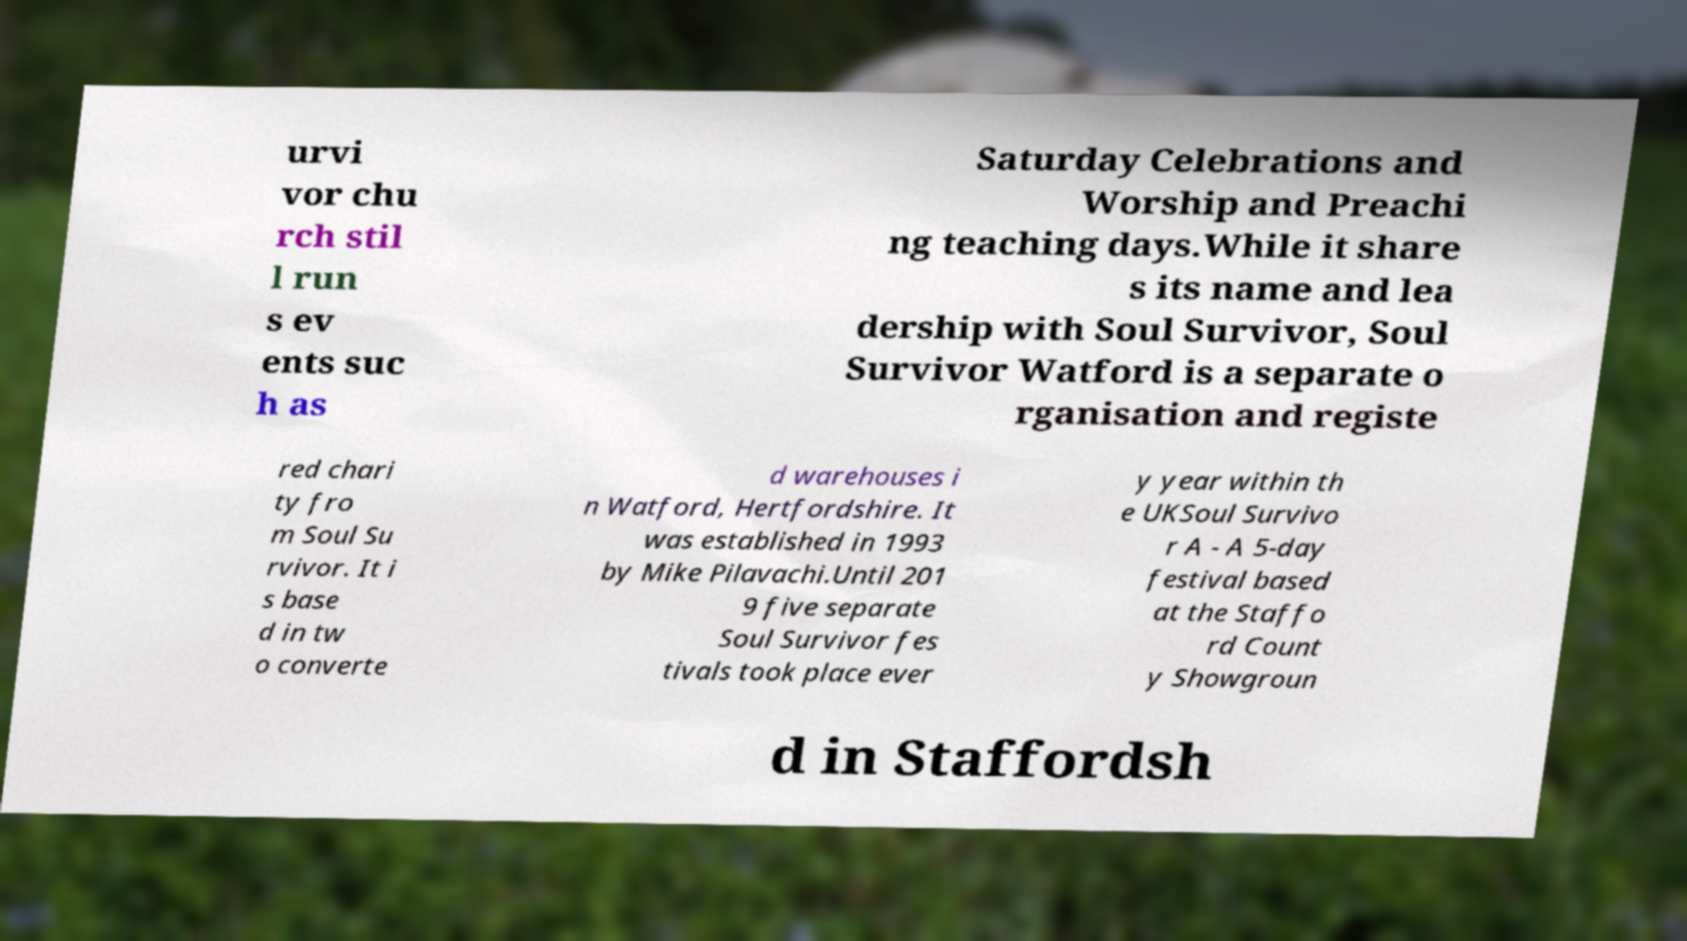Could you extract and type out the text from this image? urvi vor chu rch stil l run s ev ents suc h as Saturday Celebrations and Worship and Preachi ng teaching days.While it share s its name and lea dership with Soul Survivor, Soul Survivor Watford is a separate o rganisation and registe red chari ty fro m Soul Su rvivor. It i s base d in tw o converte d warehouses i n Watford, Hertfordshire. It was established in 1993 by Mike Pilavachi.Until 201 9 five separate Soul Survivor fes tivals took place ever y year within th e UKSoul Survivo r A - A 5-day festival based at the Staffo rd Count y Showgroun d in Staffordsh 